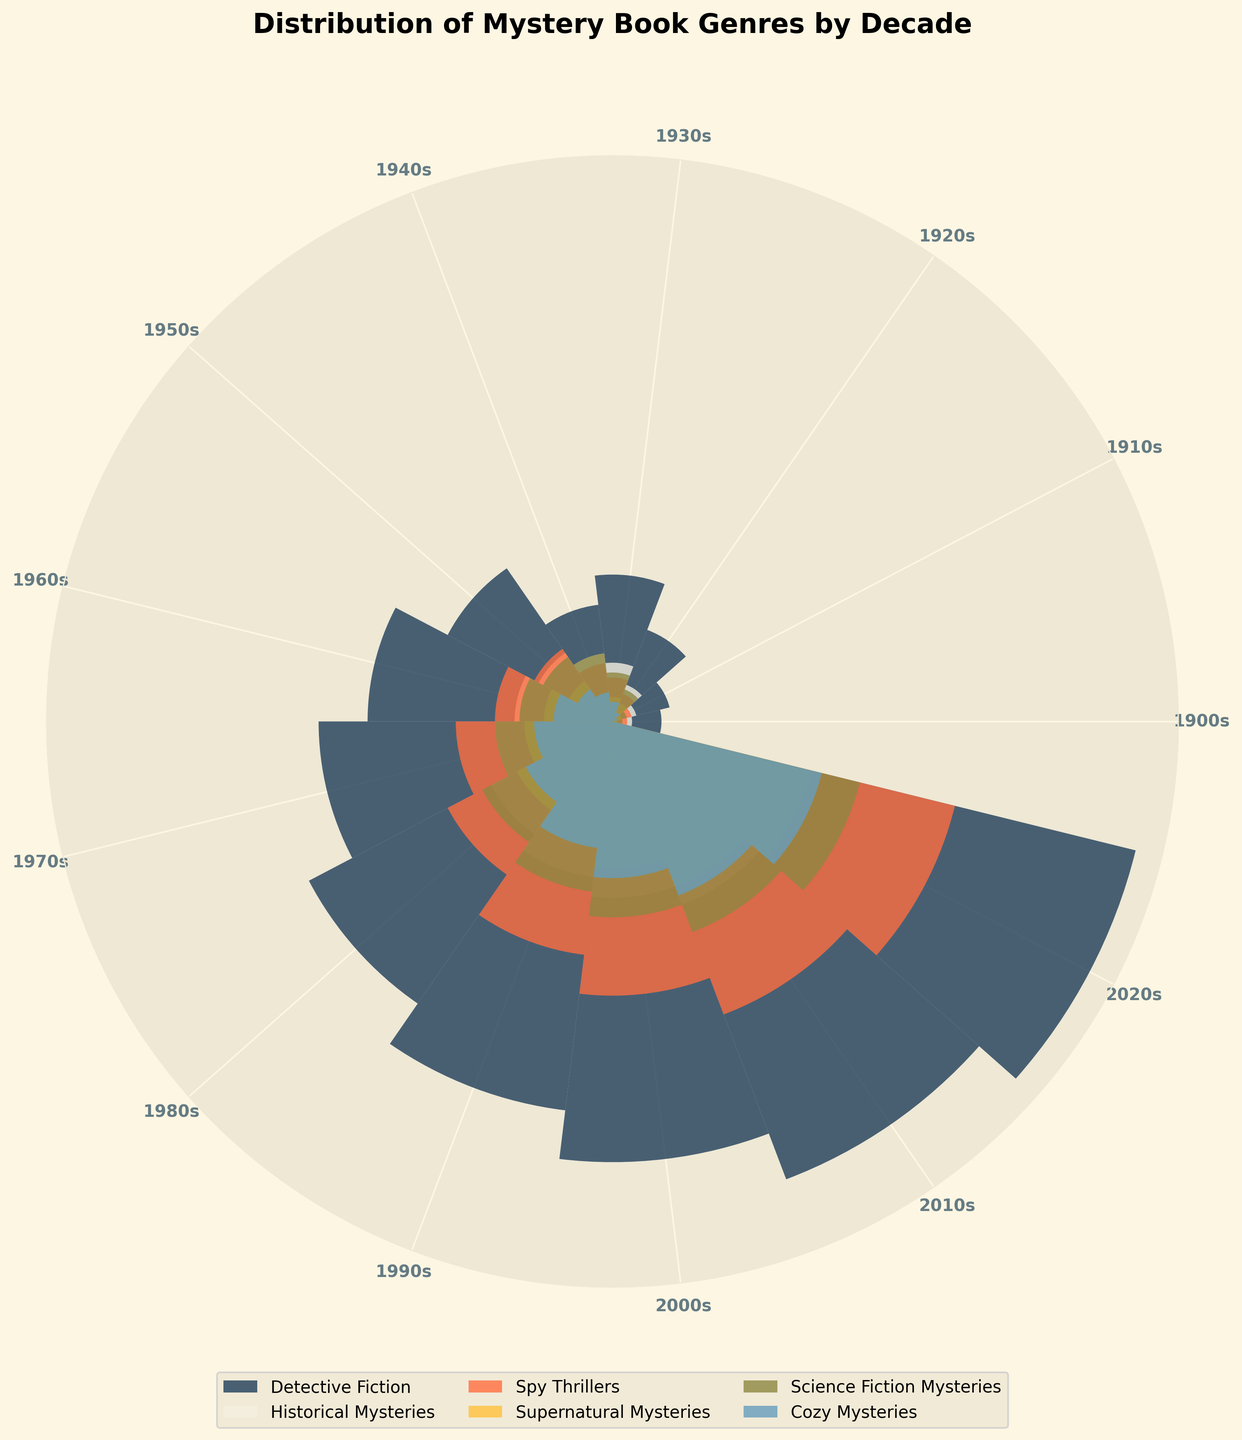What is the title of the figure? The title is usually placed at the top of the chart and describes what the chart is about. In this case, it must be read directly from the figure.
Answer: Distribution of Mystery Book Genres by Decade Which genre has the highest count in the 2010s? To find this, look at the outermost bands for the 2010s sector and identify the band with the greatest radial reach. This represents the genre with the highest count in the 2010s.
Answer: Detective Fiction How did the count of Science Fiction Mysteries change from the 1950s to the 1960s? Compare the length of the segments for Science Fiction Mysteries between the 1950s and 1960s slices. The change is seen as an increase or decrease in length.
Answer: Increased Which decades have the lowest and highest number of books published across all genres? Identify the decade with the smallest and largest outer circumference by examining the overall radius extent in each decade slice. The smallest radius corresponds to the lowest number, and the largest to the highest number.
Answer: 1900s, 2020s What is the average count of Cozy Mysteries between the 1960s and 1980s? Sum the counts of Cozy Mysteries for the 1960s, 1970s, and 1980s and divide by the number of decades (3). (60 + 80 + 100) / 3
Answer: 80 Which genre showed the most significant increase from the 1920s to the 2020s? Calculate the difference in counts for each genre between the 2020s and the 1920s and identify the genre with the highest resultant difference.
Answer: Detective Fiction How does the popularity of Supernatural Mysteries in the 1980s compare to that in the 1910s? Compare the radial length of the segment representing Supernatural Mysteries in the 1980s to that in the 1910s. The one with the longer length is more popular.
Answer: Much higher in the 1980s Among Historical Mysteries, in which decade did the smallest increase occur? Calculate the incremental increase, decade by decade, for Historical Mysteries and identify the decade transition with the smallest incremental change.
Answer: 2000s to 2010s Which genre remained consistently lower in count compared to others over the decades? Inspect each genre's relative position in every decade slice and identify the genre that stays near the center or less prominent consistently.
Answer: Cozy Mysteries By how much did Spy Thrillers increase from the 1970s to the 1990s? Subtract the count of Spy Thrillers in the 1970s from that in the 1990s to get the total increase over the period. 240 - 160 = 80
Answer: 80 